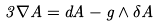<formula> <loc_0><loc_0><loc_500><loc_500>3 \nabla A = d A - g \wedge \delta A</formula> 